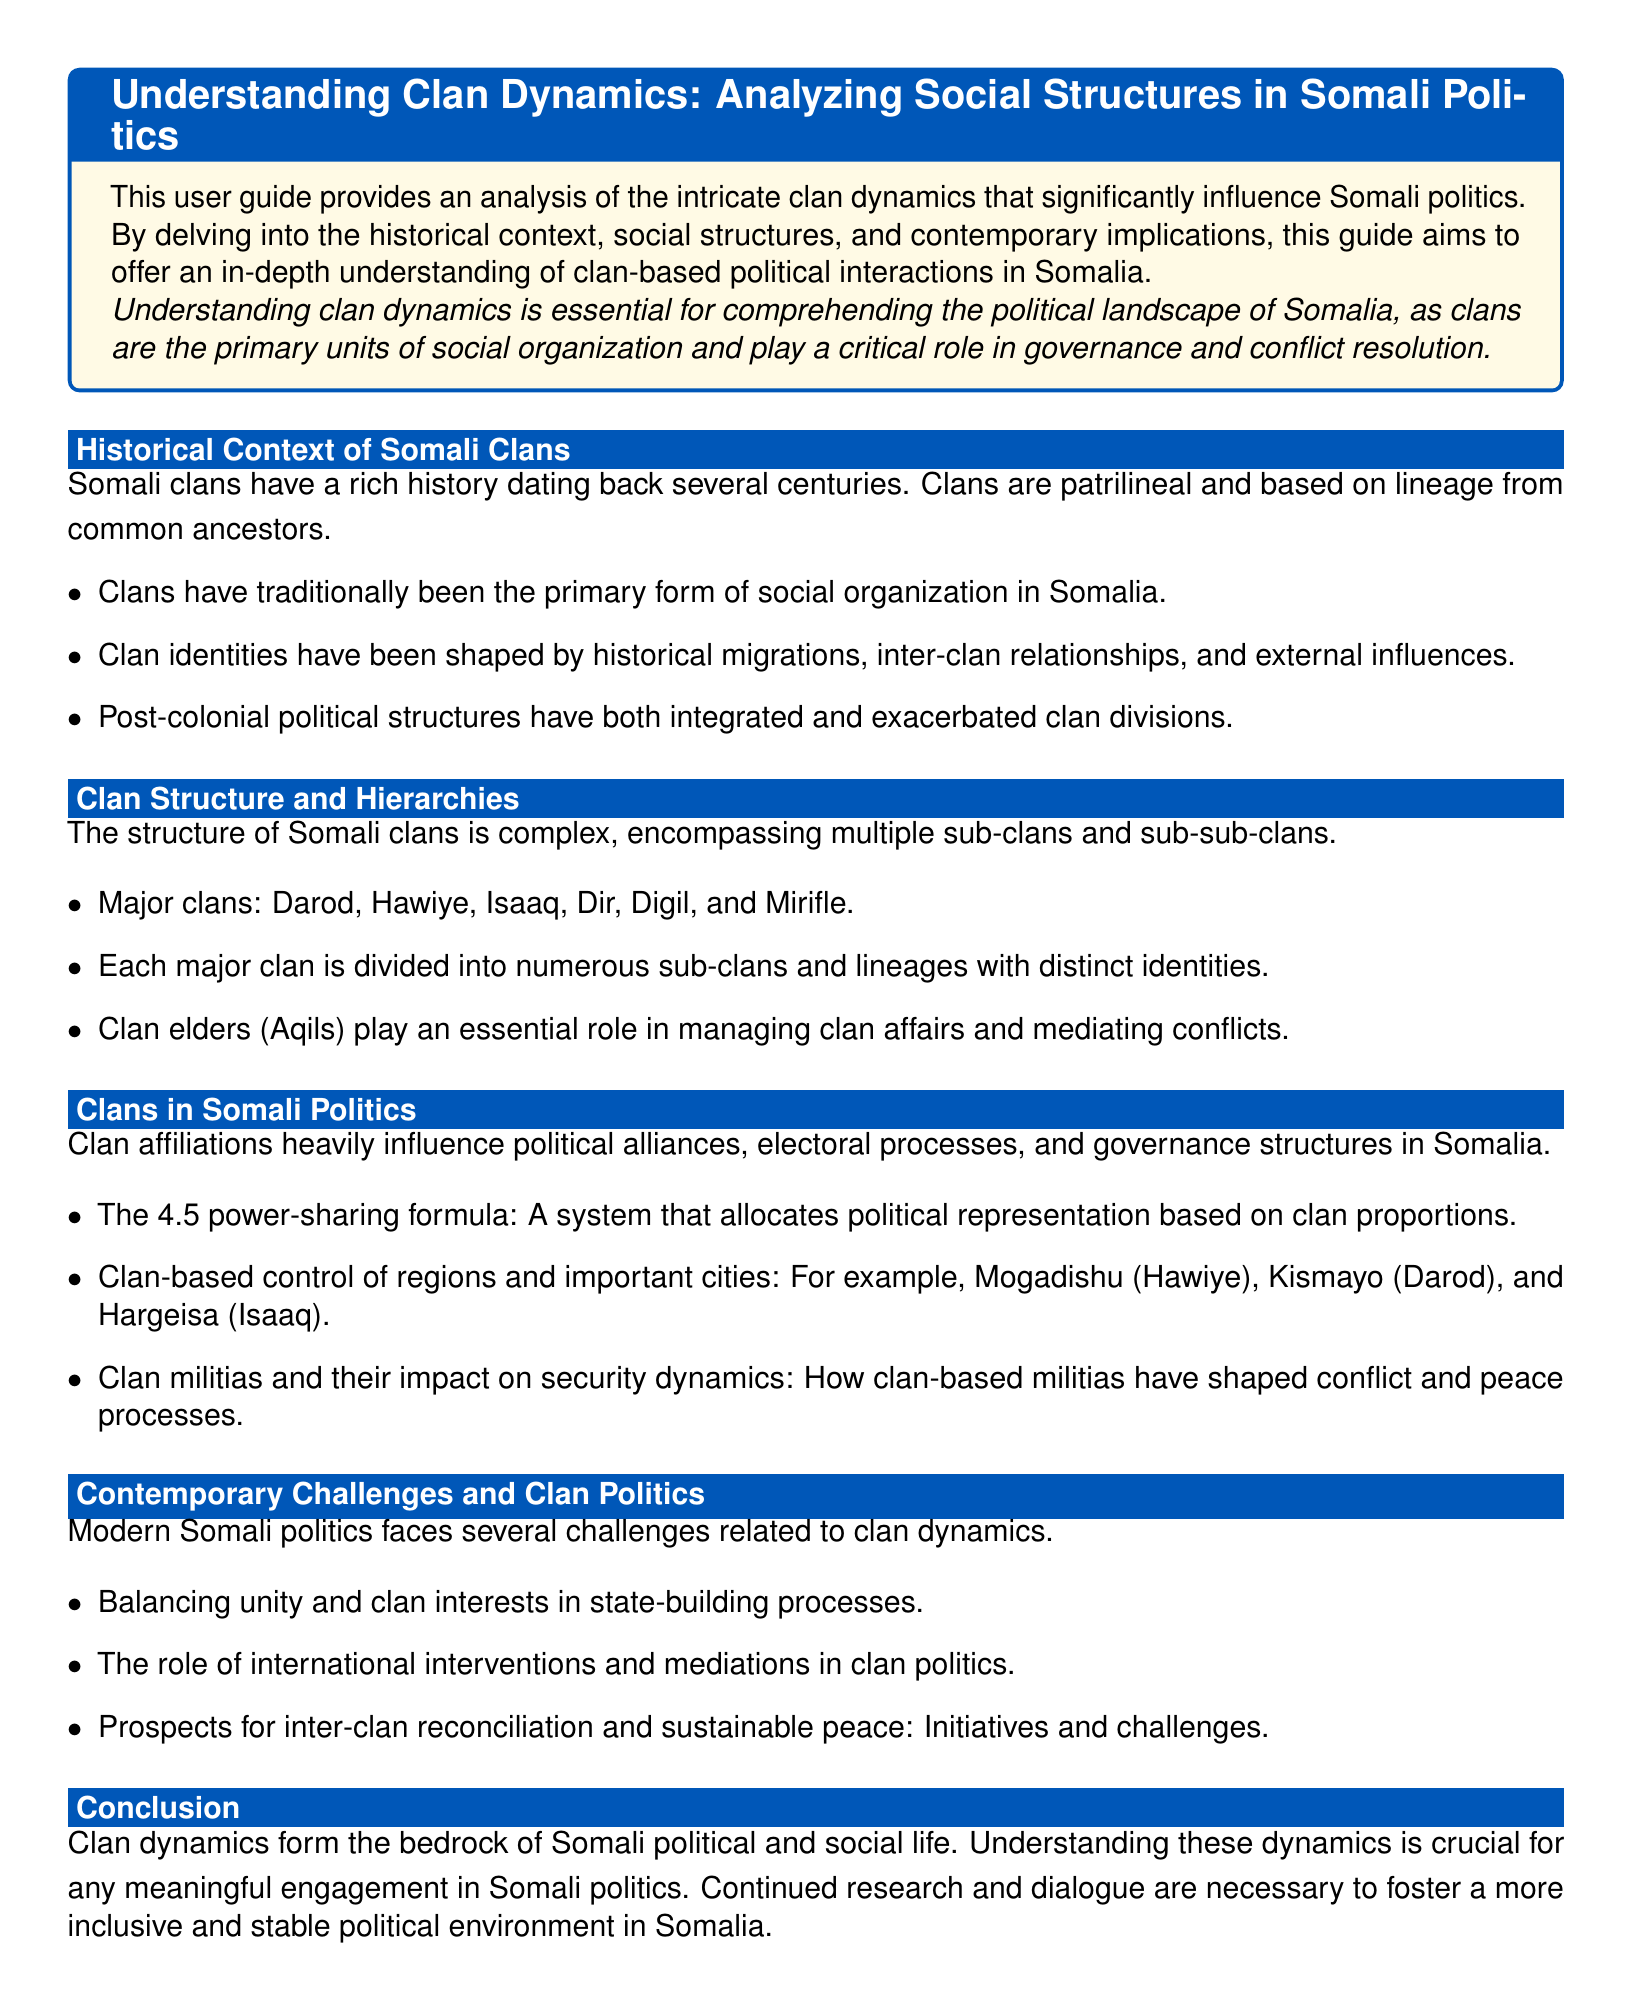What are the major clans mentioned? The document lists the major clans that include Darod, Hawiye, Isaaq, Dir, Digil, and Mirifle.
Answer: Darod, Hawiye, Isaaq, Dir, Digil, Mirifle What is the 4.5 power-sharing formula? The document defines the 4.5 power-sharing formula as a system that allocates political representation based on clan proportions.
Answer: A system that allocates political representation based on clan proportions Who plays an essential role in managing clan affairs? According to the document, clan elders (Aqils) play an essential role in managing clan affairs and mediating conflicts.
Answer: Clan elders (Aqils) What challenges does modern Somali politics face? The document states that modern Somali politics faces challenges related to balancing unity and clan interests in state-building processes.
Answer: Balancing unity and clan interests in state-building processes What historical aspect influences clan identities? The document mentions that clan identities have been shaped by historical migrations, inter-clan relationships, and external influences.
Answer: Historical migrations, inter-clan relationships, and external influences What is the primary form of social organization in Somalia? The document notes that clans have traditionally been the primary form of social organization in Somalia.
Answer: Clans Which region is controlled by the Hawiye clan? The document specifies that Mogadishu is controlled by the Hawiye clan.
Answer: Mogadishu What role do international interventions play in clan politics? According to the document, international interventions positively and negatively affect clan politics.
Answer: Positively and negatively affect clan politics How long have Somali clans existed? The document states that Somali clans have a rich history dating back several centuries.
Answer: Several centuries 